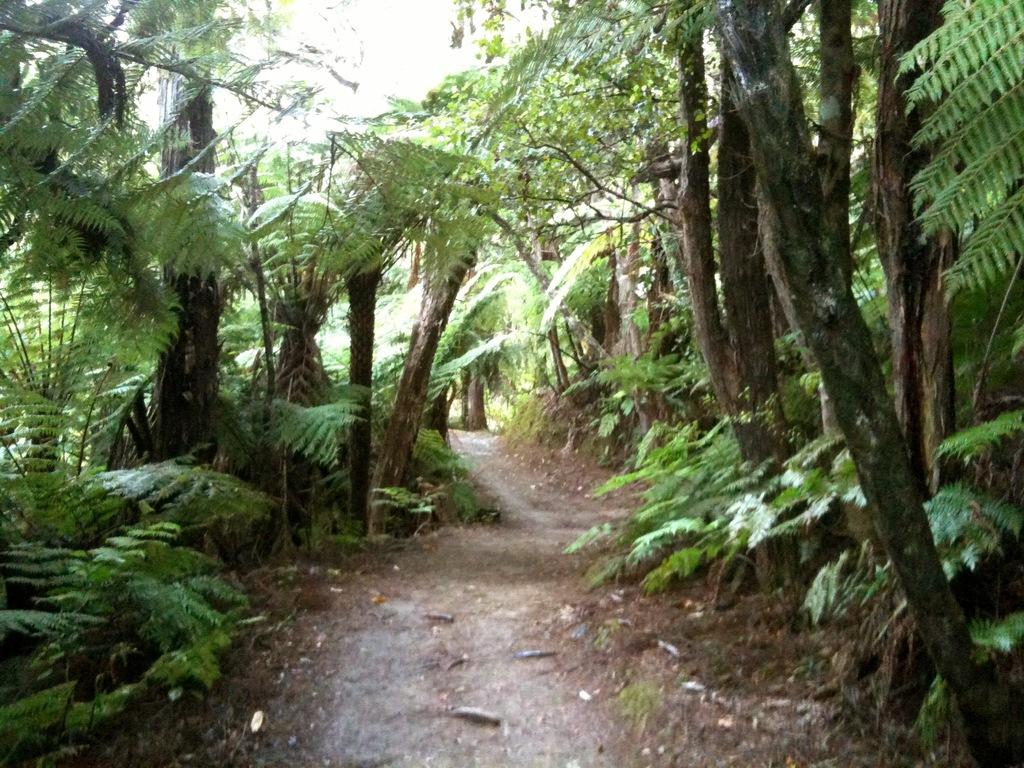Where was the image taken? The image was clicked outside the city. What can be seen in the foreground of the image? There is ground visible in the foreground of the image, along with plants. What is visible in the background of the image? There are trees and a path visible in the background of the image. What type of string is being used to measure the height of the trees in the image? There is no string or measurement activity present in the image; it simply shows trees and a path in the background. 